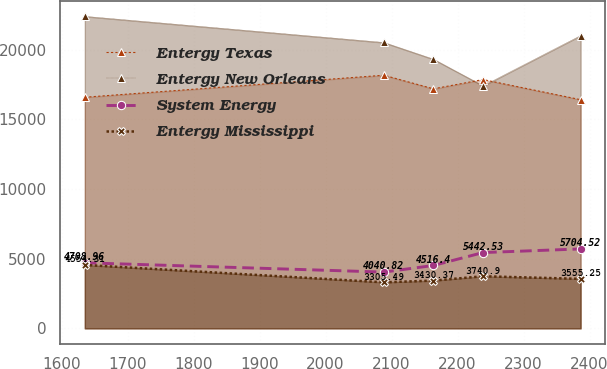Convert chart. <chart><loc_0><loc_0><loc_500><loc_500><line_chart><ecel><fcel>Entergy Texas<fcel>Entergy New Orleans<fcel>System Energy<fcel>Entergy Mississippi<nl><fcel>1635.27<fcel>16595<fcel>22404.3<fcel>4708.96<fcel>4554.31<nl><fcel>2088.32<fcel>18176.3<fcel>20526.8<fcel>4040.82<fcel>3305.49<nl><fcel>2163.43<fcel>17199.2<fcel>19325.9<fcel>4516.4<fcel>3430.37<nl><fcel>2238.54<fcel>17864.9<fcel>17415<fcel>5442.53<fcel>3740.9<nl><fcel>2386.39<fcel>16419.3<fcel>21025.7<fcel>5704.52<fcel>3555.25<nl></chart> 